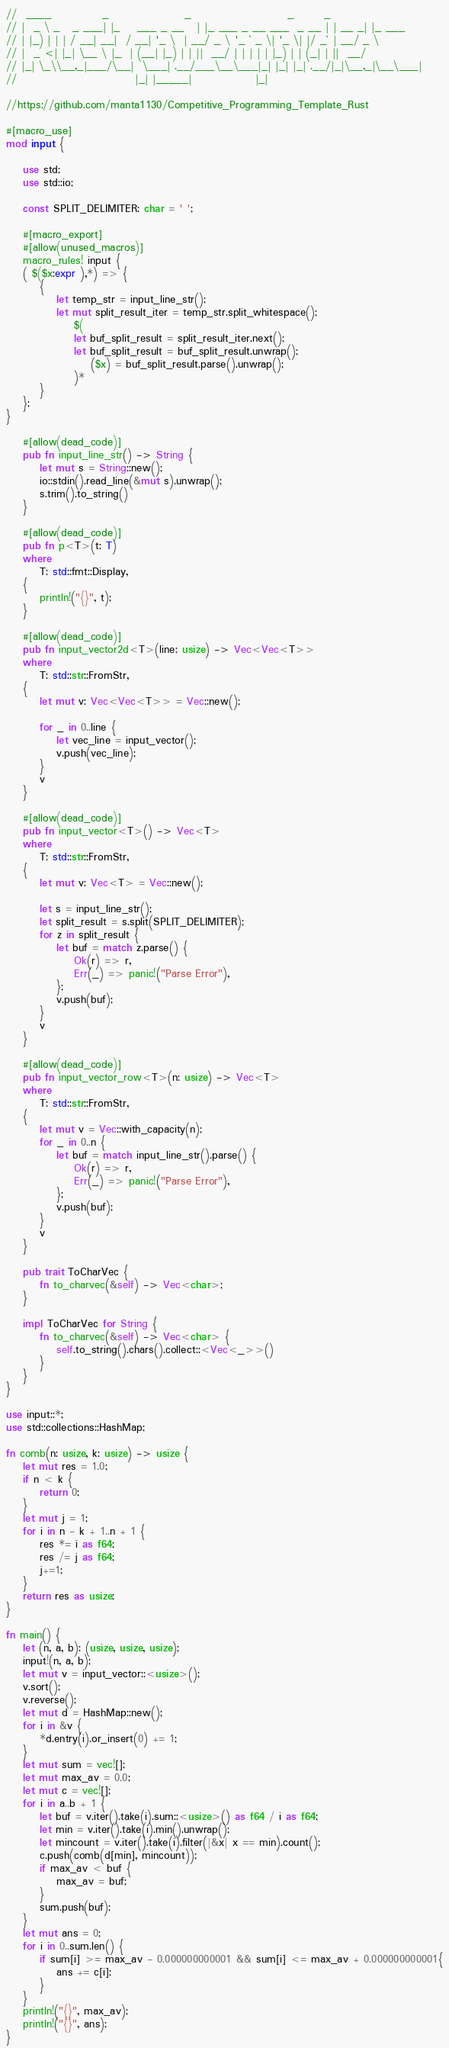<code> <loc_0><loc_0><loc_500><loc_500><_Rust_>//  ____            _                  _                       _       _
// |  _ \ _   _ ___| |_    ___ _ __   | |_ ___ _ __ ___  _ __ | | __ _| |_ ___
// | |_) | | | / __| __|  / __| '_ \  | __/ _ \ '_ ` _ \| '_ \| |/ _` | __/ _ \
// |  _ <| |_| \__ \ |_  | (__| |_) | | ||  __/ | | | | | |_) | | (_| | ||  __/
// |_| \_\\__,_|___/\__|  \___| .__/___\__\___|_| |_| |_| .__/|_|\__,_|\__\___|
//                            |_| |_____|               |_|

//https://github.com/manta1130/Competitive_Programming_Template_Rust

#[macro_use]
mod input {

    use std;
    use std::io;

    const SPLIT_DELIMITER: char = ' ';

    #[macro_export]
    #[allow(unused_macros)]
    macro_rules! input {
    ( $($x:expr ),*) => {
        {
            let temp_str = input_line_str();
            let mut split_result_iter = temp_str.split_whitespace();
                $(
                let buf_split_result = split_result_iter.next();
                let buf_split_result = buf_split_result.unwrap();
                    ($x) = buf_split_result.parse().unwrap();
                )*
        }
    };
}

    #[allow(dead_code)]
    pub fn input_line_str() -> String {
        let mut s = String::new();
        io::stdin().read_line(&mut s).unwrap();
        s.trim().to_string()
    }

    #[allow(dead_code)]
    pub fn p<T>(t: T)
    where
        T: std::fmt::Display,
    {
        println!("{}", t);
    }

    #[allow(dead_code)]
    pub fn input_vector2d<T>(line: usize) -> Vec<Vec<T>>
    where
        T: std::str::FromStr,
    {
        let mut v: Vec<Vec<T>> = Vec::new();

        for _ in 0..line {
            let vec_line = input_vector();
            v.push(vec_line);
        }
        v
    }

    #[allow(dead_code)]
    pub fn input_vector<T>() -> Vec<T>
    where
        T: std::str::FromStr,
    {
        let mut v: Vec<T> = Vec::new();

        let s = input_line_str();
        let split_result = s.split(SPLIT_DELIMITER);
        for z in split_result {
            let buf = match z.parse() {
                Ok(r) => r,
                Err(_) => panic!("Parse Error"),
            };
            v.push(buf);
        }
        v
    }

    #[allow(dead_code)]
    pub fn input_vector_row<T>(n: usize) -> Vec<T>
    where
        T: std::str::FromStr,
    {
        let mut v = Vec::with_capacity(n);
        for _ in 0..n {
            let buf = match input_line_str().parse() {
                Ok(r) => r,
                Err(_) => panic!("Parse Error"),
            };
            v.push(buf);
        }
        v
    }

    pub trait ToCharVec {
        fn to_charvec(&self) -> Vec<char>;
    }

    impl ToCharVec for String {
        fn to_charvec(&self) -> Vec<char> {
            self.to_string().chars().collect::<Vec<_>>()
        }
    }
}

use input::*;
use std::collections::HashMap;

fn comb(n: usize, k: usize) -> usize {
    let mut res = 1.0;
    if n < k {
        return 0;
    }
    let mut j = 1;
    for i in n - k + 1..n + 1 {
        res *= i as f64;
        res /= j as f64;
        j+=1;
    }
    return res as usize;
}

fn main() {
    let (n, a, b): (usize, usize, usize);
    input!(n, a, b);
    let mut v = input_vector::<usize>();
    v.sort();
    v.reverse();
    let mut d = HashMap::new();
    for i in &v {
        *d.entry(i).or_insert(0) += 1;
    }
    let mut sum = vec![];
    let mut max_av = 0.0;
    let mut c = vec![];
    for i in a..b + 1 {
        let buf = v.iter().take(i).sum::<usize>() as f64 / i as f64;
        let min = v.iter().take(i).min().unwrap();
        let mincount = v.iter().take(i).filter(|&x| x == min).count();
        c.push(comb(d[min], mincount));
        if max_av < buf {
            max_av = buf;
        }
        sum.push(buf);
    }
    let mut ans = 0;
    for i in 0..sum.len() {
        if sum[i] >= max_av - 0.000000000001 && sum[i] <= max_av + 0.000000000001{
            ans += c[i];
        }
    }
    println!("{}", max_av);
    println!("{}", ans);
}
</code> 